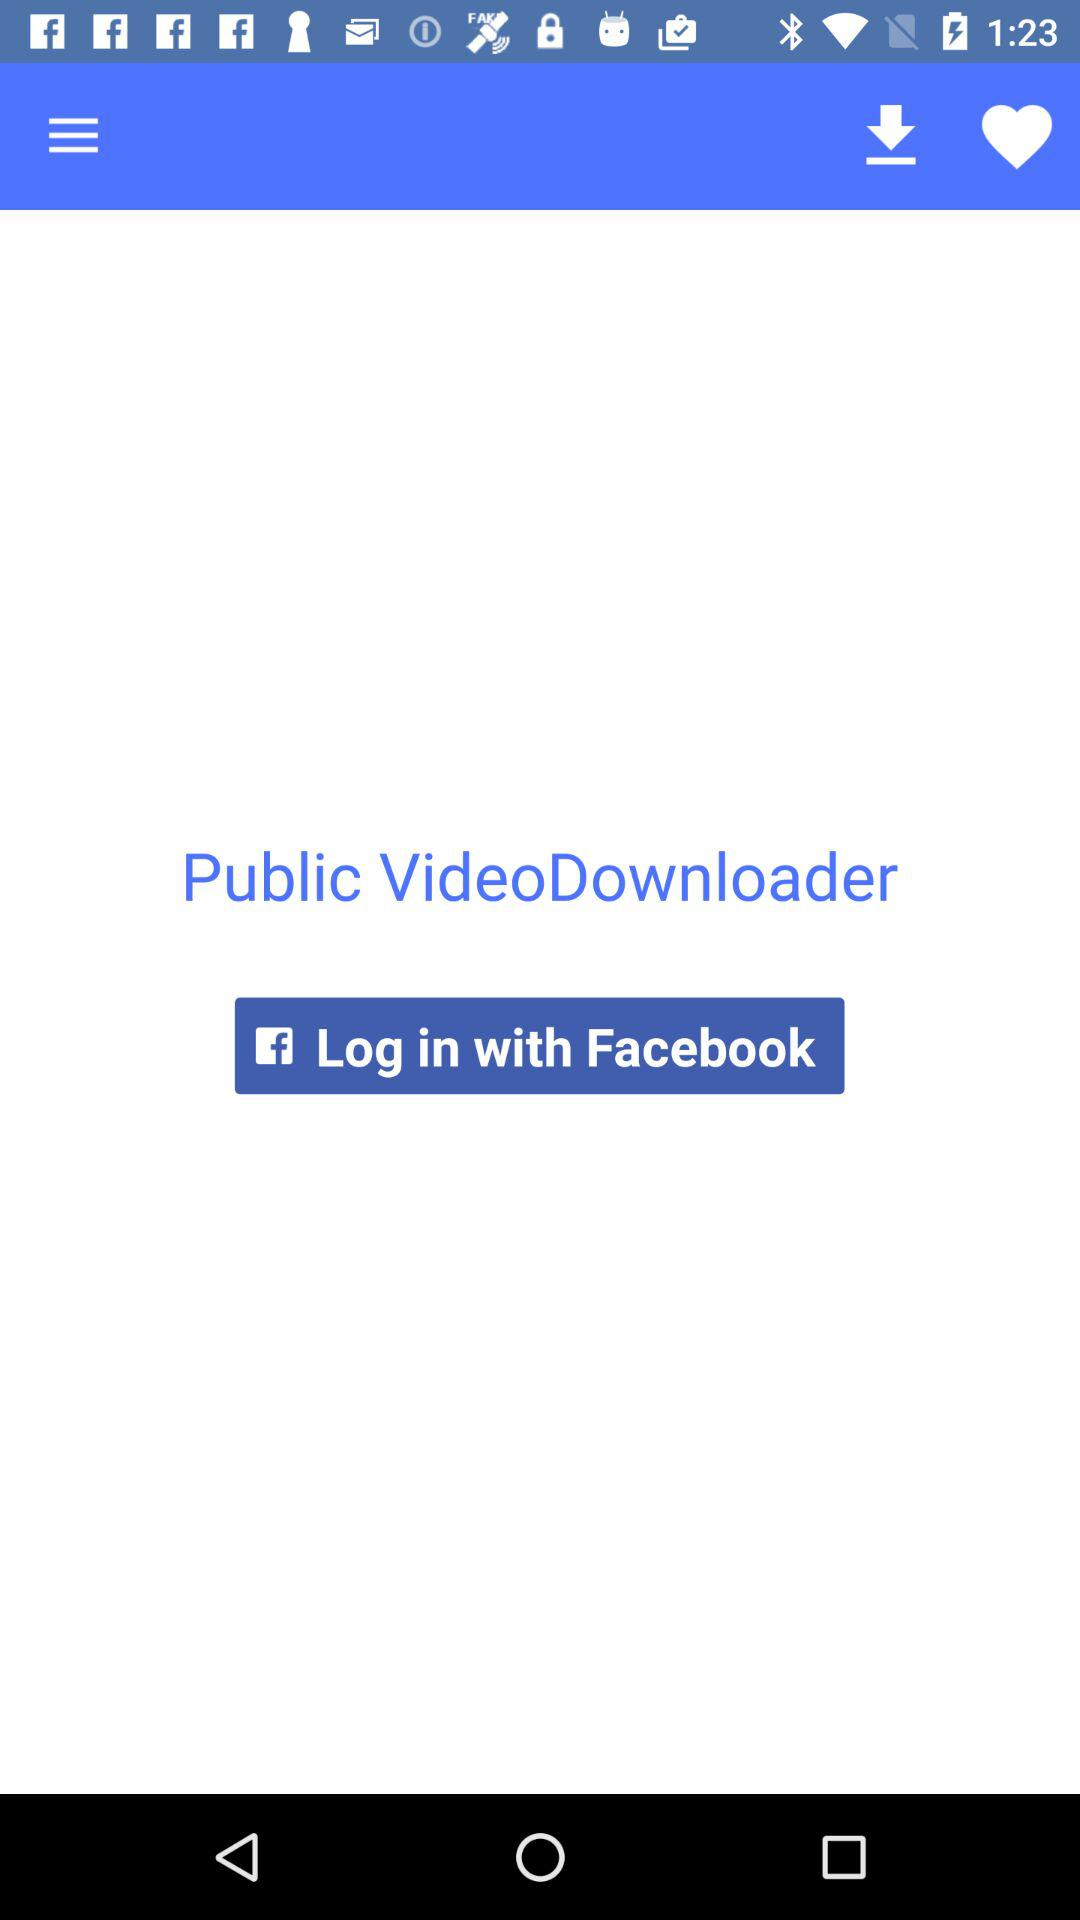How can we login? We can login with Facebook. 